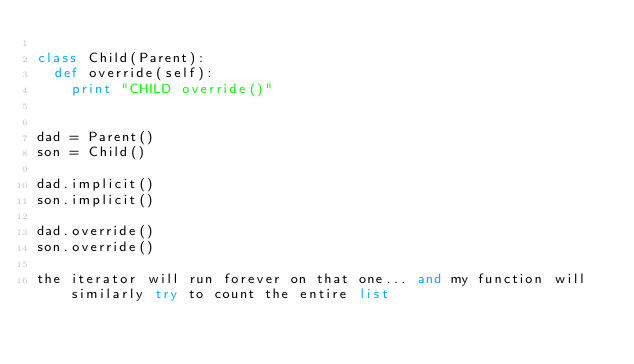Convert code to text. <code><loc_0><loc_0><loc_500><loc_500><_Python_>
class Child(Parent):
	def override(self):
		print "CHILD override()"


dad = Parent()
son = Child()

dad.implicit()
son.implicit()

dad.override()
son.override()

the iterator will run forever on that one... and my function will similarly try to count the entire list</code> 